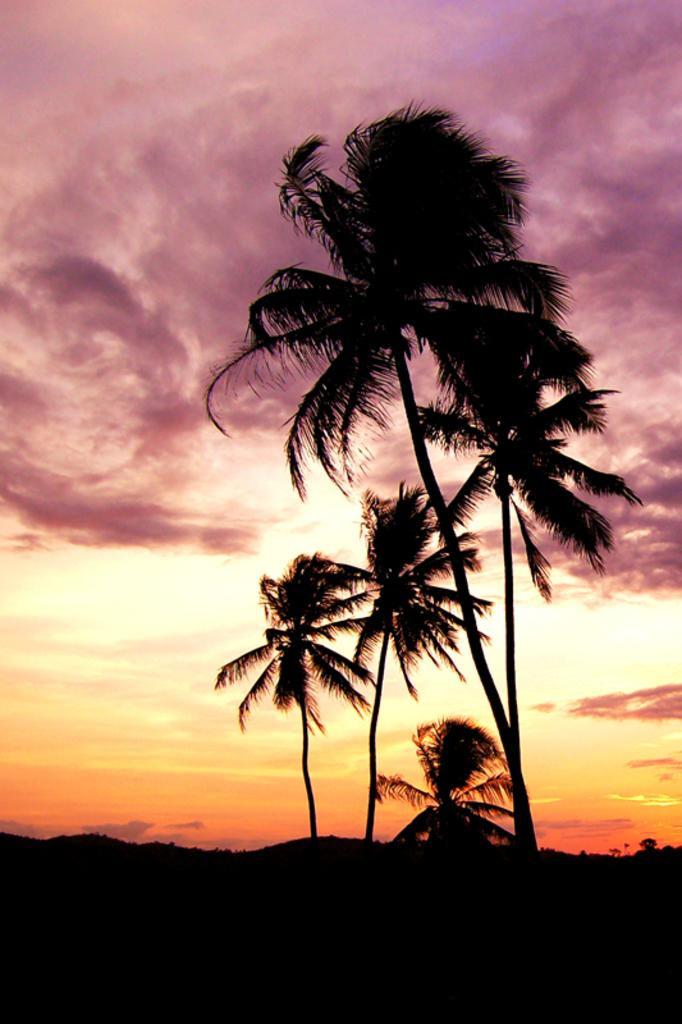What type of vegetation can be seen in the image? There are trees in the image. What is visible in the background of the image? The sky with clouds is visible in the background of the image. How would you describe the lighting in the image? The image is dark. How many bridges can be seen crossing the river in the image? There is no river or bridge present in the image; it features trees and a sky with clouds. Are there any slaves depicted in the image? There is no reference to any people, let alone slaves, in the image. 